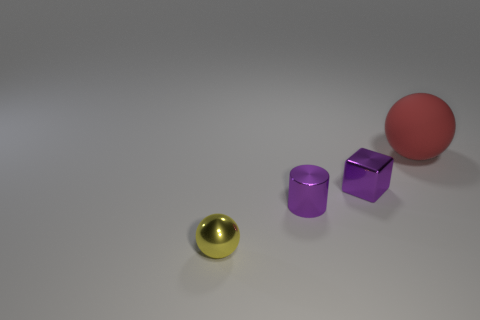Add 2 large brown matte cubes. How many objects exist? 6 Subtract all blocks. How many objects are left? 3 Subtract all small purple balls. Subtract all big balls. How many objects are left? 3 Add 2 red matte balls. How many red matte balls are left? 3 Add 2 large rubber things. How many large rubber things exist? 3 Subtract 0 green cylinders. How many objects are left? 4 